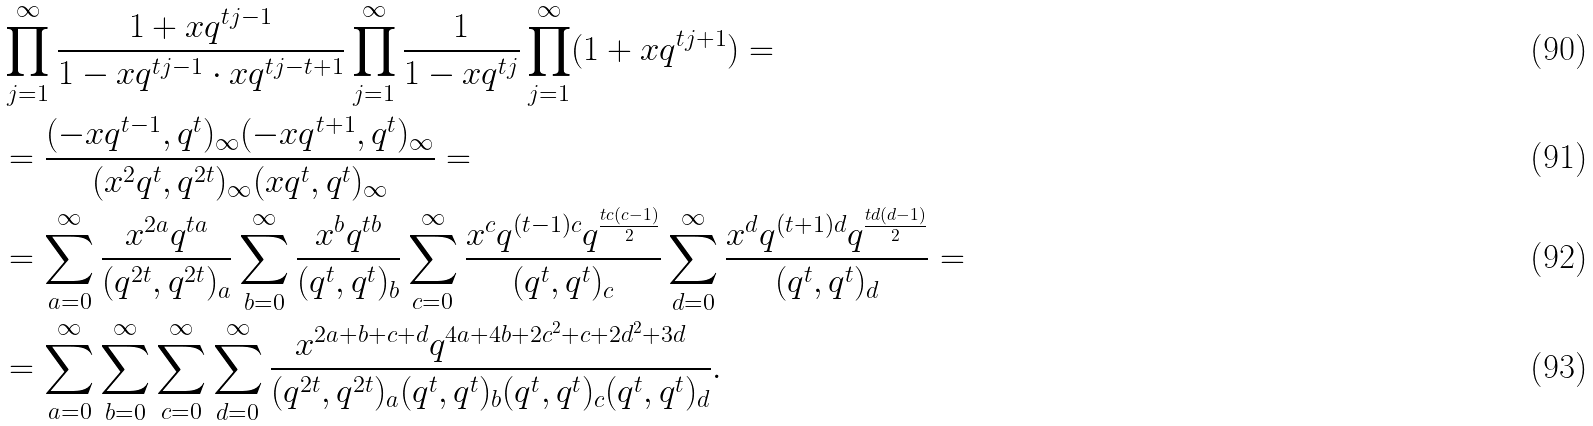<formula> <loc_0><loc_0><loc_500><loc_500>& \prod _ { j = 1 } ^ { \infty } \frac { 1 + x q ^ { t j - 1 } } { 1 - x q ^ { t j - 1 } \cdot x q ^ { t j - t + 1 } } \prod _ { j = 1 } ^ { \infty } \frac { 1 } { 1 - x q ^ { t j } } \prod _ { j = 1 } ^ { \infty } ( 1 + x q ^ { t j + 1 } ) = \\ & = \frac { ( - x q ^ { t - 1 } , q ^ { t } ) _ { \infty } ( - x q ^ { t + 1 } , q ^ { t } ) _ { \infty } } { ( x ^ { 2 } q ^ { t } , q ^ { 2 t } ) _ { \infty } ( x q ^ { t } , q ^ { t } ) _ { \infty } } = \\ & = \sum _ { a = 0 } ^ { \infty } \frac { x ^ { 2 a } q ^ { t a } } { ( q ^ { 2 t } , q ^ { 2 t } ) _ { a } } \sum _ { b = 0 } ^ { \infty } \frac { x ^ { b } q ^ { t b } } { ( q ^ { t } , q ^ { t } ) _ { b } } \sum _ { c = 0 } ^ { \infty } \frac { x ^ { c } q ^ { ( t - 1 ) c } q ^ { \frac { t c ( c - 1 ) } { 2 } } } { ( q ^ { t } , q ^ { t } ) _ { c } } \sum _ { d = 0 } ^ { \infty } \frac { x ^ { d } q ^ { ( t + 1 ) d } q ^ { \frac { t d ( d - 1 ) } { 2 } } } { ( q ^ { t } , q ^ { t } ) _ { d } } = \\ & = \sum _ { a = 0 } ^ { \infty } \sum _ { b = 0 } ^ { \infty } \sum _ { c = 0 } ^ { \infty } \sum _ { d = 0 } ^ { \infty } \frac { x ^ { 2 a + b + c + d } q ^ { 4 a + 4 b + 2 c ^ { 2 } + c + 2 d ^ { 2 } + 3 d } } { ( q ^ { 2 t } , q ^ { 2 t } ) _ { a } ( q ^ { t } , q ^ { t } ) _ { b } ( q ^ { t } , q ^ { t } ) _ { c } ( q ^ { t } , q ^ { t } ) _ { d } } .</formula> 